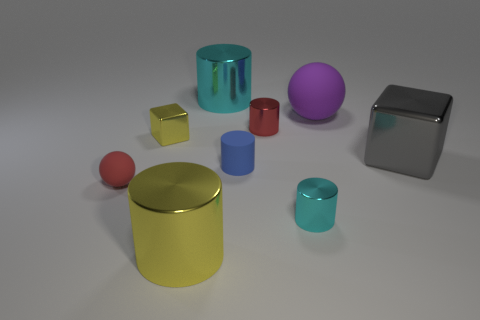Subtract all tiny cylinders. How many cylinders are left? 2 Add 1 small cyan shiny cylinders. How many objects exist? 10 Subtract all cyan cubes. How many cyan cylinders are left? 2 Subtract all red cylinders. How many cylinders are left? 4 Subtract 2 cylinders. How many cylinders are left? 3 Add 2 big gray shiny cubes. How many big gray shiny cubes exist? 3 Subtract 1 red spheres. How many objects are left? 8 Subtract all balls. How many objects are left? 7 Subtract all cyan blocks. Subtract all cyan spheres. How many blocks are left? 2 Subtract all large purple cubes. Subtract all purple things. How many objects are left? 8 